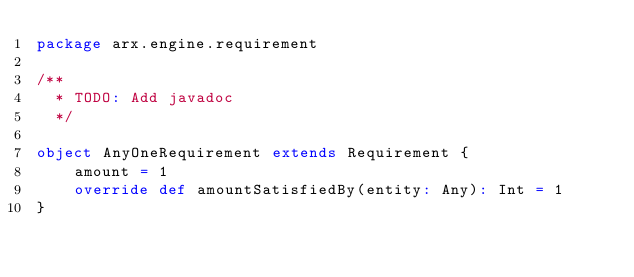Convert code to text. <code><loc_0><loc_0><loc_500><loc_500><_Scala_>package arx.engine.requirement

/**
  * TODO: Add javadoc
  */

object AnyOneRequirement extends Requirement {
	amount = 1
	override def amountSatisfiedBy(entity: Any): Int = 1
}
</code> 